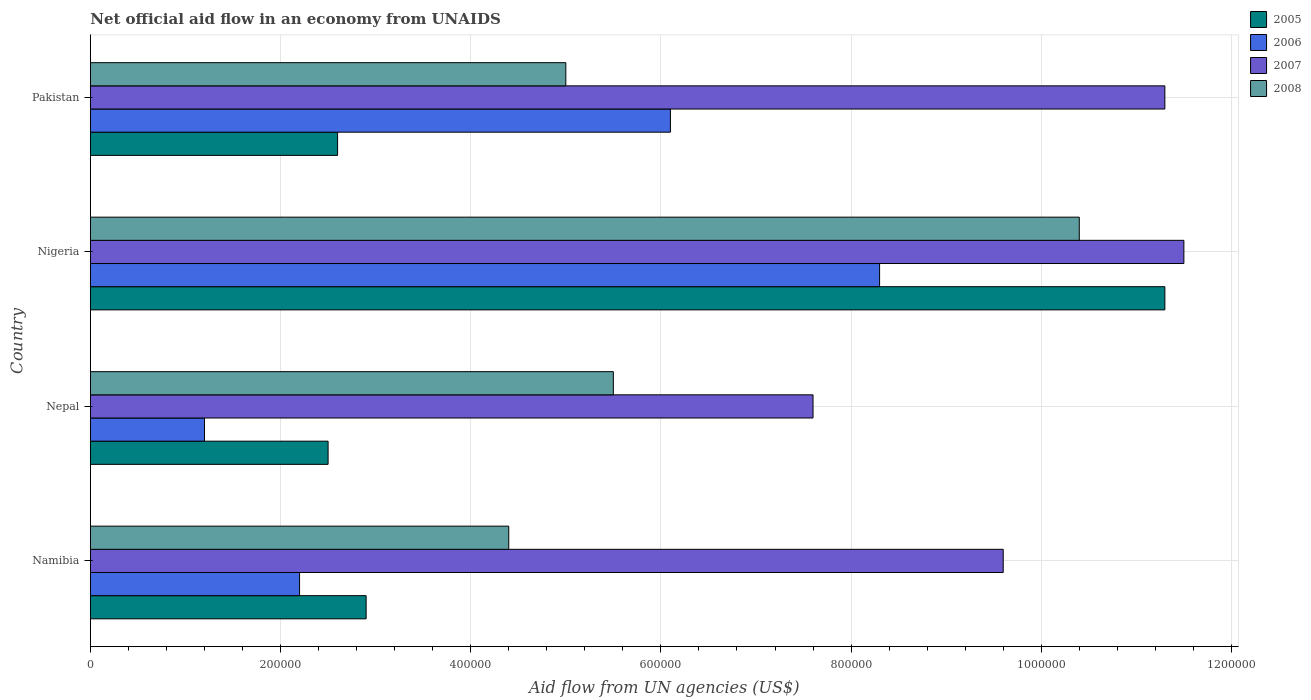How many groups of bars are there?
Keep it short and to the point. 4. What is the label of the 4th group of bars from the top?
Provide a succinct answer. Namibia. In how many cases, is the number of bars for a given country not equal to the number of legend labels?
Your answer should be very brief. 0. What is the net official aid flow in 2007 in Nigeria?
Keep it short and to the point. 1.15e+06. Across all countries, what is the maximum net official aid flow in 2006?
Your answer should be compact. 8.30e+05. In which country was the net official aid flow in 2008 maximum?
Offer a terse response. Nigeria. In which country was the net official aid flow in 2007 minimum?
Keep it short and to the point. Nepal. What is the total net official aid flow in 2005 in the graph?
Offer a very short reply. 1.93e+06. What is the difference between the net official aid flow in 2007 in Nepal and that in Pakistan?
Your answer should be very brief. -3.70e+05. What is the average net official aid flow in 2006 per country?
Ensure brevity in your answer.  4.45e+05. What is the difference between the net official aid flow in 2008 and net official aid flow in 2007 in Namibia?
Give a very brief answer. -5.20e+05. What is the ratio of the net official aid flow in 2007 in Namibia to that in Pakistan?
Ensure brevity in your answer.  0.85. Is the net official aid flow in 2006 in Nepal less than that in Pakistan?
Your response must be concise. Yes. What is the difference between the highest and the lowest net official aid flow in 2006?
Provide a succinct answer. 7.10e+05. Is it the case that in every country, the sum of the net official aid flow in 2006 and net official aid flow in 2008 is greater than the sum of net official aid flow in 2007 and net official aid flow in 2005?
Your answer should be very brief. No. What does the 3rd bar from the top in Pakistan represents?
Make the answer very short. 2006. How many countries are there in the graph?
Give a very brief answer. 4. What is the difference between two consecutive major ticks on the X-axis?
Ensure brevity in your answer.  2.00e+05. Does the graph contain any zero values?
Keep it short and to the point. No. How many legend labels are there?
Give a very brief answer. 4. How are the legend labels stacked?
Ensure brevity in your answer.  Vertical. What is the title of the graph?
Provide a succinct answer. Net official aid flow in an economy from UNAIDS. Does "1985" appear as one of the legend labels in the graph?
Offer a very short reply. No. What is the label or title of the X-axis?
Provide a short and direct response. Aid flow from UN agencies (US$). What is the Aid flow from UN agencies (US$) of 2005 in Namibia?
Offer a terse response. 2.90e+05. What is the Aid flow from UN agencies (US$) of 2006 in Namibia?
Provide a short and direct response. 2.20e+05. What is the Aid flow from UN agencies (US$) in 2007 in Namibia?
Your response must be concise. 9.60e+05. What is the Aid flow from UN agencies (US$) of 2007 in Nepal?
Provide a short and direct response. 7.60e+05. What is the Aid flow from UN agencies (US$) in 2008 in Nepal?
Offer a terse response. 5.50e+05. What is the Aid flow from UN agencies (US$) in 2005 in Nigeria?
Ensure brevity in your answer.  1.13e+06. What is the Aid flow from UN agencies (US$) of 2006 in Nigeria?
Offer a very short reply. 8.30e+05. What is the Aid flow from UN agencies (US$) in 2007 in Nigeria?
Ensure brevity in your answer.  1.15e+06. What is the Aid flow from UN agencies (US$) of 2008 in Nigeria?
Your response must be concise. 1.04e+06. What is the Aid flow from UN agencies (US$) in 2007 in Pakistan?
Offer a terse response. 1.13e+06. Across all countries, what is the maximum Aid flow from UN agencies (US$) in 2005?
Provide a succinct answer. 1.13e+06. Across all countries, what is the maximum Aid flow from UN agencies (US$) in 2006?
Ensure brevity in your answer.  8.30e+05. Across all countries, what is the maximum Aid flow from UN agencies (US$) of 2007?
Your answer should be compact. 1.15e+06. Across all countries, what is the maximum Aid flow from UN agencies (US$) of 2008?
Your response must be concise. 1.04e+06. Across all countries, what is the minimum Aid flow from UN agencies (US$) of 2005?
Provide a short and direct response. 2.50e+05. Across all countries, what is the minimum Aid flow from UN agencies (US$) in 2006?
Keep it short and to the point. 1.20e+05. Across all countries, what is the minimum Aid flow from UN agencies (US$) in 2007?
Offer a very short reply. 7.60e+05. What is the total Aid flow from UN agencies (US$) of 2005 in the graph?
Your answer should be very brief. 1.93e+06. What is the total Aid flow from UN agencies (US$) of 2006 in the graph?
Your response must be concise. 1.78e+06. What is the total Aid flow from UN agencies (US$) of 2008 in the graph?
Provide a succinct answer. 2.53e+06. What is the difference between the Aid flow from UN agencies (US$) in 2005 in Namibia and that in Nepal?
Your answer should be very brief. 4.00e+04. What is the difference between the Aid flow from UN agencies (US$) in 2005 in Namibia and that in Nigeria?
Offer a very short reply. -8.40e+05. What is the difference between the Aid flow from UN agencies (US$) in 2006 in Namibia and that in Nigeria?
Your answer should be compact. -6.10e+05. What is the difference between the Aid flow from UN agencies (US$) of 2008 in Namibia and that in Nigeria?
Your response must be concise. -6.00e+05. What is the difference between the Aid flow from UN agencies (US$) in 2006 in Namibia and that in Pakistan?
Give a very brief answer. -3.90e+05. What is the difference between the Aid flow from UN agencies (US$) in 2007 in Namibia and that in Pakistan?
Provide a short and direct response. -1.70e+05. What is the difference between the Aid flow from UN agencies (US$) of 2008 in Namibia and that in Pakistan?
Ensure brevity in your answer.  -6.00e+04. What is the difference between the Aid flow from UN agencies (US$) in 2005 in Nepal and that in Nigeria?
Ensure brevity in your answer.  -8.80e+05. What is the difference between the Aid flow from UN agencies (US$) of 2006 in Nepal and that in Nigeria?
Your response must be concise. -7.10e+05. What is the difference between the Aid flow from UN agencies (US$) of 2007 in Nepal and that in Nigeria?
Your answer should be very brief. -3.90e+05. What is the difference between the Aid flow from UN agencies (US$) of 2008 in Nepal and that in Nigeria?
Offer a very short reply. -4.90e+05. What is the difference between the Aid flow from UN agencies (US$) in 2006 in Nepal and that in Pakistan?
Offer a very short reply. -4.90e+05. What is the difference between the Aid flow from UN agencies (US$) of 2007 in Nepal and that in Pakistan?
Ensure brevity in your answer.  -3.70e+05. What is the difference between the Aid flow from UN agencies (US$) in 2005 in Nigeria and that in Pakistan?
Your response must be concise. 8.70e+05. What is the difference between the Aid flow from UN agencies (US$) in 2006 in Nigeria and that in Pakistan?
Provide a short and direct response. 2.20e+05. What is the difference between the Aid flow from UN agencies (US$) of 2007 in Nigeria and that in Pakistan?
Give a very brief answer. 2.00e+04. What is the difference between the Aid flow from UN agencies (US$) in 2008 in Nigeria and that in Pakistan?
Make the answer very short. 5.40e+05. What is the difference between the Aid flow from UN agencies (US$) of 2005 in Namibia and the Aid flow from UN agencies (US$) of 2006 in Nepal?
Your answer should be compact. 1.70e+05. What is the difference between the Aid flow from UN agencies (US$) of 2005 in Namibia and the Aid flow from UN agencies (US$) of 2007 in Nepal?
Your response must be concise. -4.70e+05. What is the difference between the Aid flow from UN agencies (US$) of 2005 in Namibia and the Aid flow from UN agencies (US$) of 2008 in Nepal?
Ensure brevity in your answer.  -2.60e+05. What is the difference between the Aid flow from UN agencies (US$) of 2006 in Namibia and the Aid flow from UN agencies (US$) of 2007 in Nepal?
Make the answer very short. -5.40e+05. What is the difference between the Aid flow from UN agencies (US$) of 2006 in Namibia and the Aid flow from UN agencies (US$) of 2008 in Nepal?
Offer a very short reply. -3.30e+05. What is the difference between the Aid flow from UN agencies (US$) in 2005 in Namibia and the Aid flow from UN agencies (US$) in 2006 in Nigeria?
Your response must be concise. -5.40e+05. What is the difference between the Aid flow from UN agencies (US$) of 2005 in Namibia and the Aid flow from UN agencies (US$) of 2007 in Nigeria?
Your answer should be compact. -8.60e+05. What is the difference between the Aid flow from UN agencies (US$) of 2005 in Namibia and the Aid flow from UN agencies (US$) of 2008 in Nigeria?
Your answer should be compact. -7.50e+05. What is the difference between the Aid flow from UN agencies (US$) in 2006 in Namibia and the Aid flow from UN agencies (US$) in 2007 in Nigeria?
Keep it short and to the point. -9.30e+05. What is the difference between the Aid flow from UN agencies (US$) in 2006 in Namibia and the Aid flow from UN agencies (US$) in 2008 in Nigeria?
Your response must be concise. -8.20e+05. What is the difference between the Aid flow from UN agencies (US$) in 2007 in Namibia and the Aid flow from UN agencies (US$) in 2008 in Nigeria?
Offer a terse response. -8.00e+04. What is the difference between the Aid flow from UN agencies (US$) in 2005 in Namibia and the Aid flow from UN agencies (US$) in 2006 in Pakistan?
Your answer should be very brief. -3.20e+05. What is the difference between the Aid flow from UN agencies (US$) of 2005 in Namibia and the Aid flow from UN agencies (US$) of 2007 in Pakistan?
Offer a terse response. -8.40e+05. What is the difference between the Aid flow from UN agencies (US$) of 2006 in Namibia and the Aid flow from UN agencies (US$) of 2007 in Pakistan?
Offer a very short reply. -9.10e+05. What is the difference between the Aid flow from UN agencies (US$) of 2006 in Namibia and the Aid flow from UN agencies (US$) of 2008 in Pakistan?
Provide a short and direct response. -2.80e+05. What is the difference between the Aid flow from UN agencies (US$) in 2007 in Namibia and the Aid flow from UN agencies (US$) in 2008 in Pakistan?
Make the answer very short. 4.60e+05. What is the difference between the Aid flow from UN agencies (US$) of 2005 in Nepal and the Aid flow from UN agencies (US$) of 2006 in Nigeria?
Ensure brevity in your answer.  -5.80e+05. What is the difference between the Aid flow from UN agencies (US$) of 2005 in Nepal and the Aid flow from UN agencies (US$) of 2007 in Nigeria?
Offer a very short reply. -9.00e+05. What is the difference between the Aid flow from UN agencies (US$) in 2005 in Nepal and the Aid flow from UN agencies (US$) in 2008 in Nigeria?
Your answer should be very brief. -7.90e+05. What is the difference between the Aid flow from UN agencies (US$) of 2006 in Nepal and the Aid flow from UN agencies (US$) of 2007 in Nigeria?
Offer a very short reply. -1.03e+06. What is the difference between the Aid flow from UN agencies (US$) in 2006 in Nepal and the Aid flow from UN agencies (US$) in 2008 in Nigeria?
Make the answer very short. -9.20e+05. What is the difference between the Aid flow from UN agencies (US$) of 2007 in Nepal and the Aid flow from UN agencies (US$) of 2008 in Nigeria?
Your response must be concise. -2.80e+05. What is the difference between the Aid flow from UN agencies (US$) in 2005 in Nepal and the Aid flow from UN agencies (US$) in 2006 in Pakistan?
Offer a terse response. -3.60e+05. What is the difference between the Aid flow from UN agencies (US$) of 2005 in Nepal and the Aid flow from UN agencies (US$) of 2007 in Pakistan?
Provide a short and direct response. -8.80e+05. What is the difference between the Aid flow from UN agencies (US$) in 2005 in Nepal and the Aid flow from UN agencies (US$) in 2008 in Pakistan?
Make the answer very short. -2.50e+05. What is the difference between the Aid flow from UN agencies (US$) in 2006 in Nepal and the Aid flow from UN agencies (US$) in 2007 in Pakistan?
Ensure brevity in your answer.  -1.01e+06. What is the difference between the Aid flow from UN agencies (US$) of 2006 in Nepal and the Aid flow from UN agencies (US$) of 2008 in Pakistan?
Keep it short and to the point. -3.80e+05. What is the difference between the Aid flow from UN agencies (US$) in 2005 in Nigeria and the Aid flow from UN agencies (US$) in 2006 in Pakistan?
Your response must be concise. 5.20e+05. What is the difference between the Aid flow from UN agencies (US$) of 2005 in Nigeria and the Aid flow from UN agencies (US$) of 2008 in Pakistan?
Your answer should be compact. 6.30e+05. What is the difference between the Aid flow from UN agencies (US$) of 2007 in Nigeria and the Aid flow from UN agencies (US$) of 2008 in Pakistan?
Your answer should be compact. 6.50e+05. What is the average Aid flow from UN agencies (US$) of 2005 per country?
Make the answer very short. 4.82e+05. What is the average Aid flow from UN agencies (US$) in 2006 per country?
Give a very brief answer. 4.45e+05. What is the average Aid flow from UN agencies (US$) in 2008 per country?
Make the answer very short. 6.32e+05. What is the difference between the Aid flow from UN agencies (US$) of 2005 and Aid flow from UN agencies (US$) of 2006 in Namibia?
Offer a very short reply. 7.00e+04. What is the difference between the Aid flow from UN agencies (US$) in 2005 and Aid flow from UN agencies (US$) in 2007 in Namibia?
Your answer should be compact. -6.70e+05. What is the difference between the Aid flow from UN agencies (US$) of 2006 and Aid flow from UN agencies (US$) of 2007 in Namibia?
Your answer should be compact. -7.40e+05. What is the difference between the Aid flow from UN agencies (US$) in 2006 and Aid flow from UN agencies (US$) in 2008 in Namibia?
Offer a very short reply. -2.20e+05. What is the difference between the Aid flow from UN agencies (US$) of 2007 and Aid flow from UN agencies (US$) of 2008 in Namibia?
Make the answer very short. 5.20e+05. What is the difference between the Aid flow from UN agencies (US$) in 2005 and Aid flow from UN agencies (US$) in 2007 in Nepal?
Offer a terse response. -5.10e+05. What is the difference between the Aid flow from UN agencies (US$) in 2006 and Aid flow from UN agencies (US$) in 2007 in Nepal?
Keep it short and to the point. -6.40e+05. What is the difference between the Aid flow from UN agencies (US$) in 2006 and Aid flow from UN agencies (US$) in 2008 in Nepal?
Make the answer very short. -4.30e+05. What is the difference between the Aid flow from UN agencies (US$) of 2005 and Aid flow from UN agencies (US$) of 2008 in Nigeria?
Keep it short and to the point. 9.00e+04. What is the difference between the Aid flow from UN agencies (US$) of 2006 and Aid flow from UN agencies (US$) of 2007 in Nigeria?
Ensure brevity in your answer.  -3.20e+05. What is the difference between the Aid flow from UN agencies (US$) of 2005 and Aid flow from UN agencies (US$) of 2006 in Pakistan?
Provide a succinct answer. -3.50e+05. What is the difference between the Aid flow from UN agencies (US$) in 2005 and Aid flow from UN agencies (US$) in 2007 in Pakistan?
Keep it short and to the point. -8.70e+05. What is the difference between the Aid flow from UN agencies (US$) of 2006 and Aid flow from UN agencies (US$) of 2007 in Pakistan?
Give a very brief answer. -5.20e+05. What is the difference between the Aid flow from UN agencies (US$) of 2006 and Aid flow from UN agencies (US$) of 2008 in Pakistan?
Give a very brief answer. 1.10e+05. What is the difference between the Aid flow from UN agencies (US$) of 2007 and Aid flow from UN agencies (US$) of 2008 in Pakistan?
Ensure brevity in your answer.  6.30e+05. What is the ratio of the Aid flow from UN agencies (US$) of 2005 in Namibia to that in Nepal?
Keep it short and to the point. 1.16. What is the ratio of the Aid flow from UN agencies (US$) of 2006 in Namibia to that in Nepal?
Your answer should be compact. 1.83. What is the ratio of the Aid flow from UN agencies (US$) of 2007 in Namibia to that in Nepal?
Offer a terse response. 1.26. What is the ratio of the Aid flow from UN agencies (US$) in 2005 in Namibia to that in Nigeria?
Offer a very short reply. 0.26. What is the ratio of the Aid flow from UN agencies (US$) of 2006 in Namibia to that in Nigeria?
Ensure brevity in your answer.  0.27. What is the ratio of the Aid flow from UN agencies (US$) in 2007 in Namibia to that in Nigeria?
Offer a very short reply. 0.83. What is the ratio of the Aid flow from UN agencies (US$) of 2008 in Namibia to that in Nigeria?
Your answer should be compact. 0.42. What is the ratio of the Aid flow from UN agencies (US$) of 2005 in Namibia to that in Pakistan?
Ensure brevity in your answer.  1.12. What is the ratio of the Aid flow from UN agencies (US$) in 2006 in Namibia to that in Pakistan?
Offer a very short reply. 0.36. What is the ratio of the Aid flow from UN agencies (US$) in 2007 in Namibia to that in Pakistan?
Offer a very short reply. 0.85. What is the ratio of the Aid flow from UN agencies (US$) of 2008 in Namibia to that in Pakistan?
Your answer should be very brief. 0.88. What is the ratio of the Aid flow from UN agencies (US$) in 2005 in Nepal to that in Nigeria?
Your response must be concise. 0.22. What is the ratio of the Aid flow from UN agencies (US$) of 2006 in Nepal to that in Nigeria?
Offer a terse response. 0.14. What is the ratio of the Aid flow from UN agencies (US$) of 2007 in Nepal to that in Nigeria?
Offer a terse response. 0.66. What is the ratio of the Aid flow from UN agencies (US$) in 2008 in Nepal to that in Nigeria?
Keep it short and to the point. 0.53. What is the ratio of the Aid flow from UN agencies (US$) of 2005 in Nepal to that in Pakistan?
Give a very brief answer. 0.96. What is the ratio of the Aid flow from UN agencies (US$) in 2006 in Nepal to that in Pakistan?
Provide a succinct answer. 0.2. What is the ratio of the Aid flow from UN agencies (US$) in 2007 in Nepal to that in Pakistan?
Provide a short and direct response. 0.67. What is the ratio of the Aid flow from UN agencies (US$) of 2005 in Nigeria to that in Pakistan?
Keep it short and to the point. 4.35. What is the ratio of the Aid flow from UN agencies (US$) in 2006 in Nigeria to that in Pakistan?
Offer a very short reply. 1.36. What is the ratio of the Aid flow from UN agencies (US$) of 2007 in Nigeria to that in Pakistan?
Make the answer very short. 1.02. What is the ratio of the Aid flow from UN agencies (US$) in 2008 in Nigeria to that in Pakistan?
Offer a very short reply. 2.08. What is the difference between the highest and the second highest Aid flow from UN agencies (US$) of 2005?
Make the answer very short. 8.40e+05. What is the difference between the highest and the second highest Aid flow from UN agencies (US$) of 2007?
Your answer should be compact. 2.00e+04. What is the difference between the highest and the second highest Aid flow from UN agencies (US$) of 2008?
Your answer should be compact. 4.90e+05. What is the difference between the highest and the lowest Aid flow from UN agencies (US$) of 2005?
Offer a terse response. 8.80e+05. What is the difference between the highest and the lowest Aid flow from UN agencies (US$) of 2006?
Your answer should be very brief. 7.10e+05. 